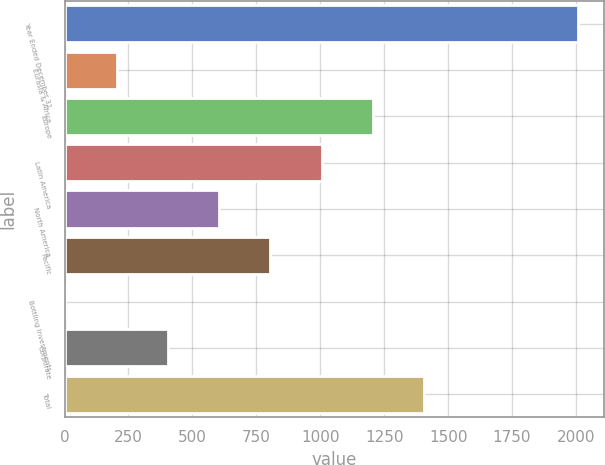Convert chart to OTSL. <chart><loc_0><loc_0><loc_500><loc_500><bar_chart><fcel>Year Ended December 31<fcel>Eurasia & Africa<fcel>Europe<fcel>Latin America<fcel>North America<fcel>Pacific<fcel>Bottling Investments<fcel>Corporate<fcel>Total<nl><fcel>2008<fcel>203.59<fcel>1206.04<fcel>1005.55<fcel>604.57<fcel>805.06<fcel>3.1<fcel>404.08<fcel>1406.53<nl></chart> 